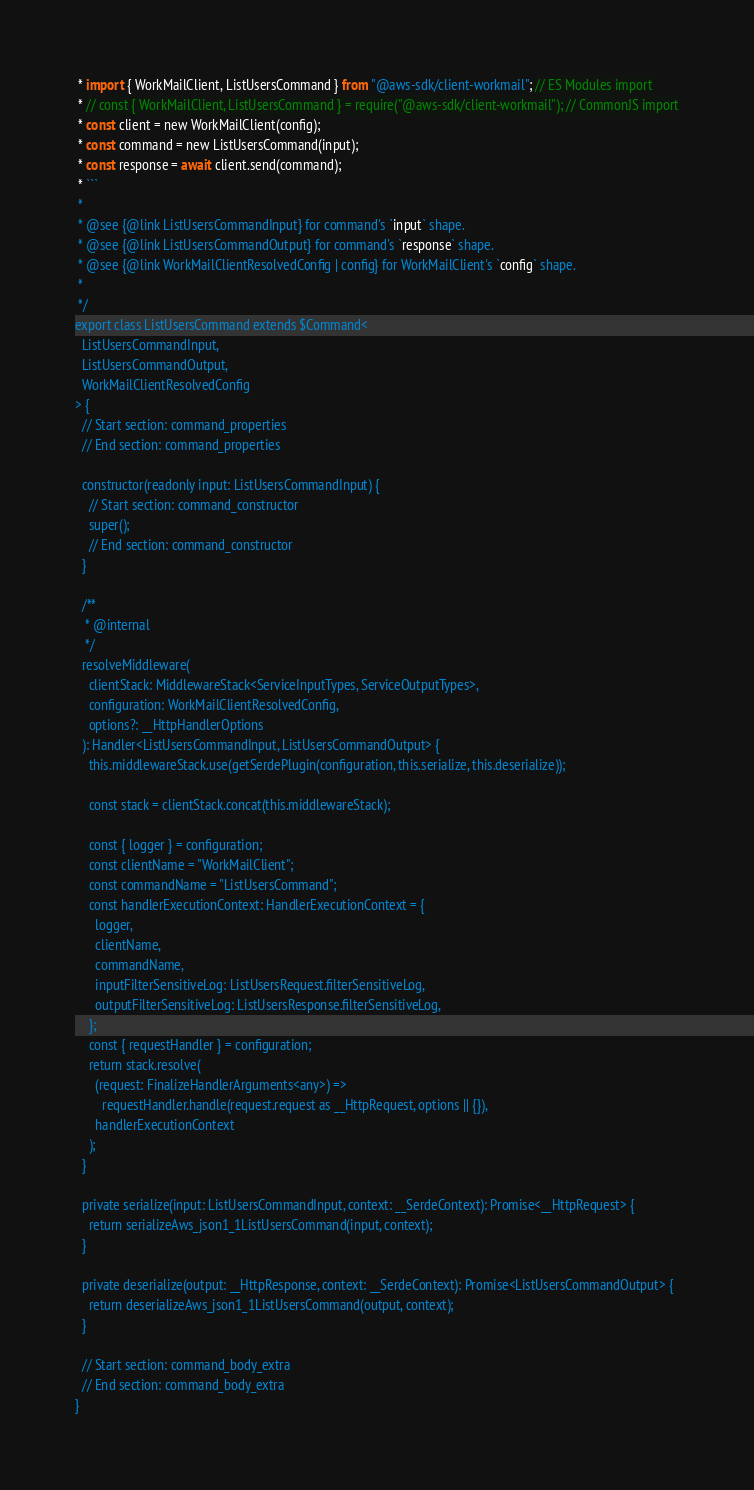<code> <loc_0><loc_0><loc_500><loc_500><_TypeScript_> * import { WorkMailClient, ListUsersCommand } from "@aws-sdk/client-workmail"; // ES Modules import
 * // const { WorkMailClient, ListUsersCommand } = require("@aws-sdk/client-workmail"); // CommonJS import
 * const client = new WorkMailClient(config);
 * const command = new ListUsersCommand(input);
 * const response = await client.send(command);
 * ```
 *
 * @see {@link ListUsersCommandInput} for command's `input` shape.
 * @see {@link ListUsersCommandOutput} for command's `response` shape.
 * @see {@link WorkMailClientResolvedConfig | config} for WorkMailClient's `config` shape.
 *
 */
export class ListUsersCommand extends $Command<
  ListUsersCommandInput,
  ListUsersCommandOutput,
  WorkMailClientResolvedConfig
> {
  // Start section: command_properties
  // End section: command_properties

  constructor(readonly input: ListUsersCommandInput) {
    // Start section: command_constructor
    super();
    // End section: command_constructor
  }

  /**
   * @internal
   */
  resolveMiddleware(
    clientStack: MiddlewareStack<ServiceInputTypes, ServiceOutputTypes>,
    configuration: WorkMailClientResolvedConfig,
    options?: __HttpHandlerOptions
  ): Handler<ListUsersCommandInput, ListUsersCommandOutput> {
    this.middlewareStack.use(getSerdePlugin(configuration, this.serialize, this.deserialize));

    const stack = clientStack.concat(this.middlewareStack);

    const { logger } = configuration;
    const clientName = "WorkMailClient";
    const commandName = "ListUsersCommand";
    const handlerExecutionContext: HandlerExecutionContext = {
      logger,
      clientName,
      commandName,
      inputFilterSensitiveLog: ListUsersRequest.filterSensitiveLog,
      outputFilterSensitiveLog: ListUsersResponse.filterSensitiveLog,
    };
    const { requestHandler } = configuration;
    return stack.resolve(
      (request: FinalizeHandlerArguments<any>) =>
        requestHandler.handle(request.request as __HttpRequest, options || {}),
      handlerExecutionContext
    );
  }

  private serialize(input: ListUsersCommandInput, context: __SerdeContext): Promise<__HttpRequest> {
    return serializeAws_json1_1ListUsersCommand(input, context);
  }

  private deserialize(output: __HttpResponse, context: __SerdeContext): Promise<ListUsersCommandOutput> {
    return deserializeAws_json1_1ListUsersCommand(output, context);
  }

  // Start section: command_body_extra
  // End section: command_body_extra
}
</code> 